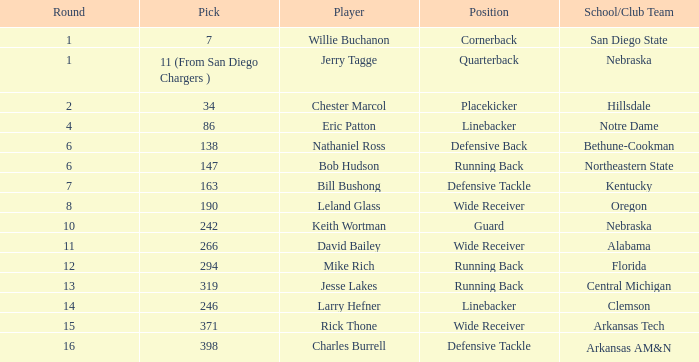Which pick has a school/club team that is kentucky? 163.0. Give me the full table as a dictionary. {'header': ['Round', 'Pick', 'Player', 'Position', 'School/Club Team'], 'rows': [['1', '7', 'Willie Buchanon', 'Cornerback', 'San Diego State'], ['1', '11 (From San Diego Chargers )', 'Jerry Tagge', 'Quarterback', 'Nebraska'], ['2', '34', 'Chester Marcol', 'Placekicker', 'Hillsdale'], ['4', '86', 'Eric Patton', 'Linebacker', 'Notre Dame'], ['6', '138', 'Nathaniel Ross', 'Defensive Back', 'Bethune-Cookman'], ['6', '147', 'Bob Hudson', 'Running Back', 'Northeastern State'], ['7', '163', 'Bill Bushong', 'Defensive Tackle', 'Kentucky'], ['8', '190', 'Leland Glass', 'Wide Receiver', 'Oregon'], ['10', '242', 'Keith Wortman', 'Guard', 'Nebraska'], ['11', '266', 'David Bailey', 'Wide Receiver', 'Alabama'], ['12', '294', 'Mike Rich', 'Running Back', 'Florida'], ['13', '319', 'Jesse Lakes', 'Running Back', 'Central Michigan'], ['14', '246', 'Larry Hefner', 'Linebacker', 'Clemson'], ['15', '371', 'Rick Thone', 'Wide Receiver', 'Arkansas Tech'], ['16', '398', 'Charles Burrell', 'Defensive Tackle', 'Arkansas AM&N']]} 